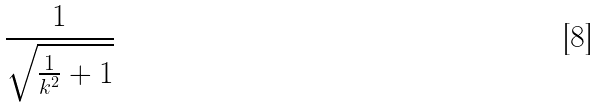Convert formula to latex. <formula><loc_0><loc_0><loc_500><loc_500>\frac { 1 } { \sqrt { \frac { 1 } { k ^ { 2 } } + 1 } }</formula> 